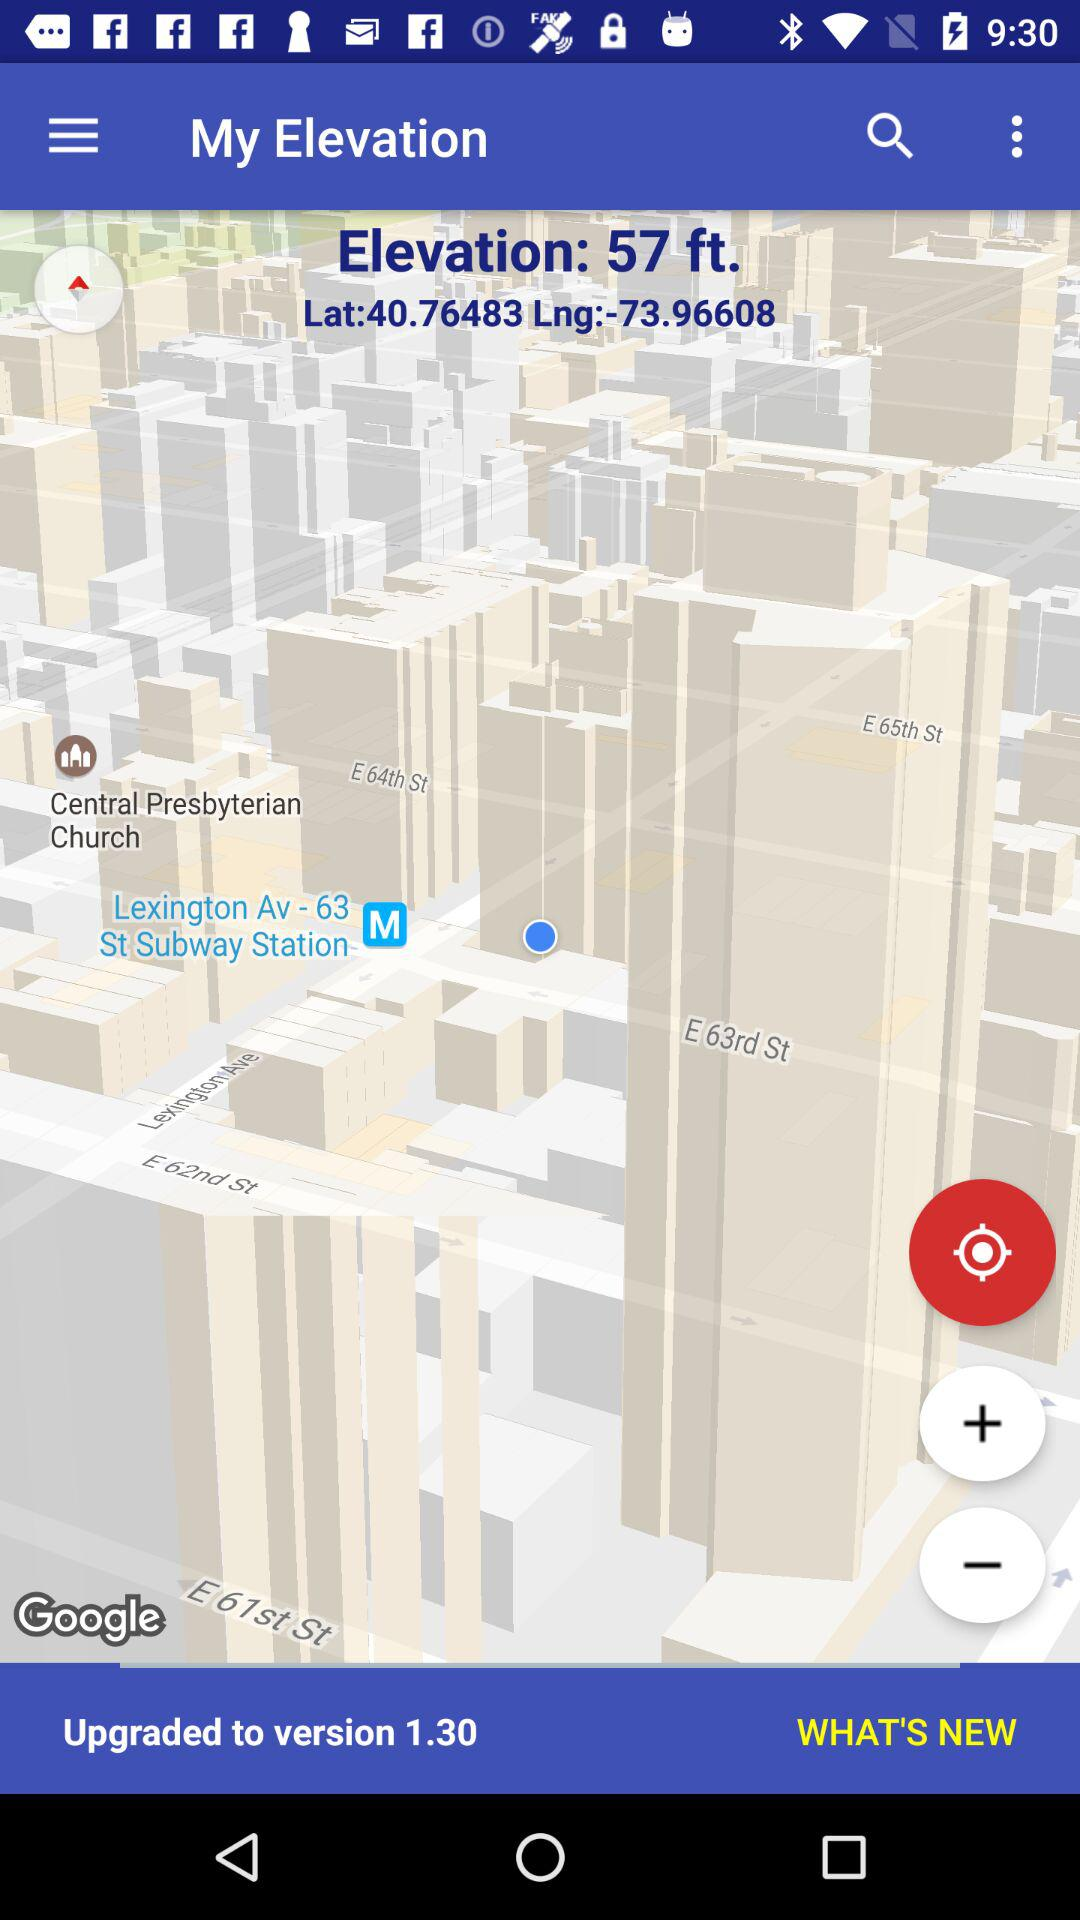What is the latitude? The latitude is 40.76483. 